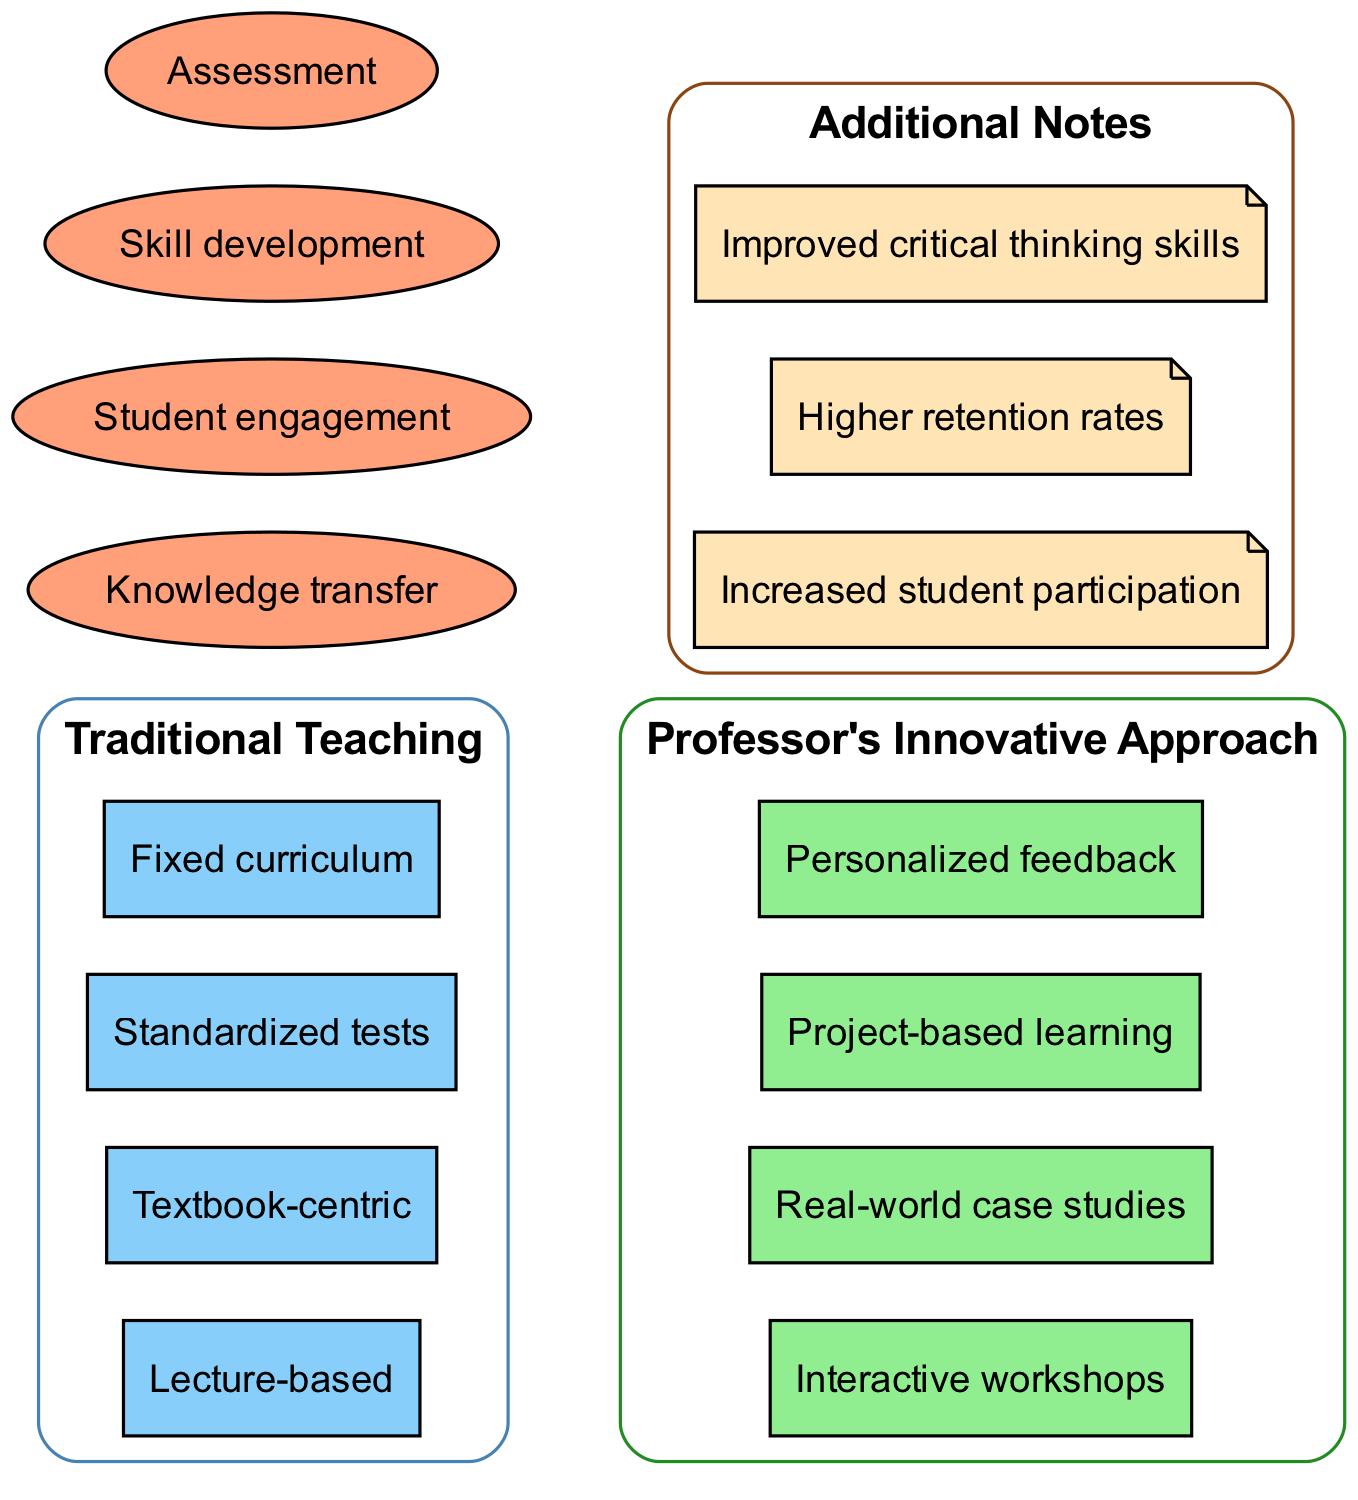What are the elements of traditional teaching methods? The traditional teaching methods include "Lecture-based," "Textbook-centric," "Standardized tests," and "Fixed curriculum," which are listed under the Traditional Teaching circle.
Answer: Lecture-based, Textbook-centric, Standardized tests, Fixed curriculum What are the unique aspects of the professor's innovative approach? The innovative approach includes "Interactive workshops," "Real-world case studies," "Project-based learning," and "Personalized feedback," found exclusively in the Professor's Innovative Approach circle.
Answer: Interactive workshops, Real-world case studies, Project-based learning, Personalized feedback How many overlapping elements are there between the two teaching methods? The overlap includes "Knowledge transfer," "Student engagement," "Skill development," and "Assessment," totaling four elements when counted.
Answer: 4 What is one unique benefit mentioned in the additional notes? The additional notes highlight benefits such as "Increased student participation," which contributes to the effectiveness of the innovative approach.
Answer: Increased student participation How does the traditional teaching focus on knowledge transfer relate to student engagement? Both "Knowledge transfer" and "Student engagement" are covered in the overlap section, suggesting that this method can facilitate student engagement as well.
Answer: Overlap of knowledge transfer and student engagement Which method includes more interactive learning elements? The professor's innovative approach includes interactive elements like "Interactive workshops" and "Project-based learning," indicating a focus on engaging students actively.
Answer: Professor's Innovative Approach What is the direct relationship between fixed curriculum and personalized feedback in this diagram? "Fixed curriculum" falls under traditional teaching, which denotes a rigid structure, while "Personalized feedback" from the innovative approach signifies adaptability, revealing contrasting educational strategies.
Answer: Contrasting relationship Which teaching method employs standardized tests? The "Traditional Teaching" method utilizes "Standardized tests" as an assessment strategy, indicated within its designated circle.
Answer: Traditional Teaching What shared aspect enhances both teaching methods? "Skill development" is an aspect that overlaps both methods, indicating that both approaches aim to contribute to this area, albeit perhaps in different ways.
Answer: Skill development 